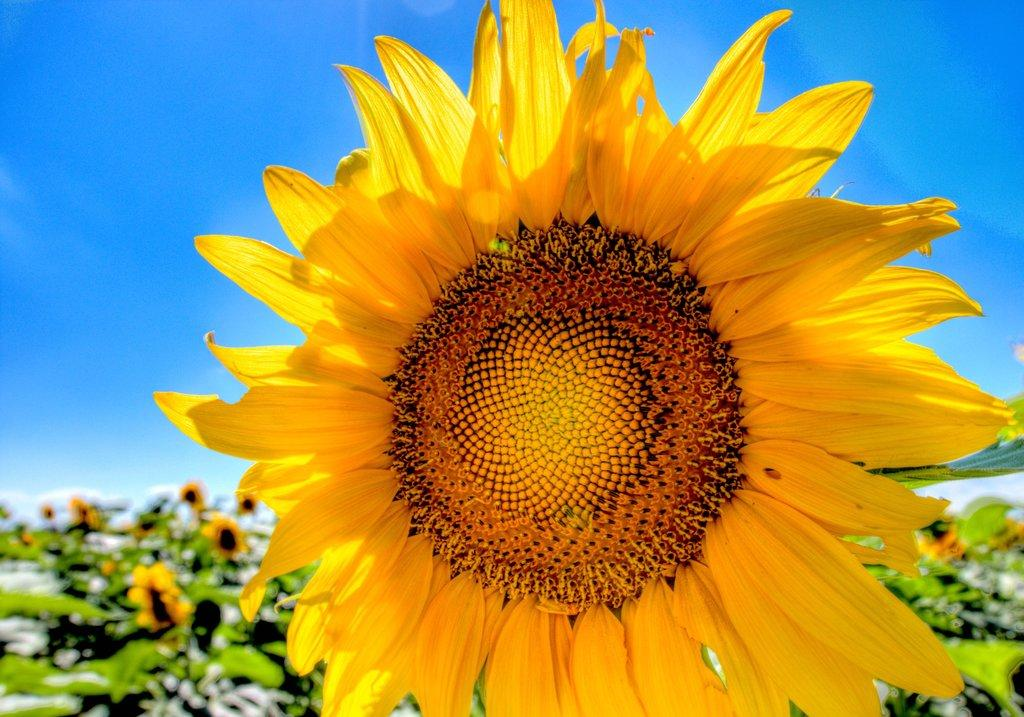What is the main subject in the middle of the image? There is a sunflower in the middle of the image. What else can be seen in the background of the image? There are plants with flowers in the background of the image. What is visible at the top of the image? The sky is visible at the top of the image. What type of hammer is being used to create the fire in the image? There is no hammer or fire present in the image; it features a sunflower and plants with flowers in the background. 